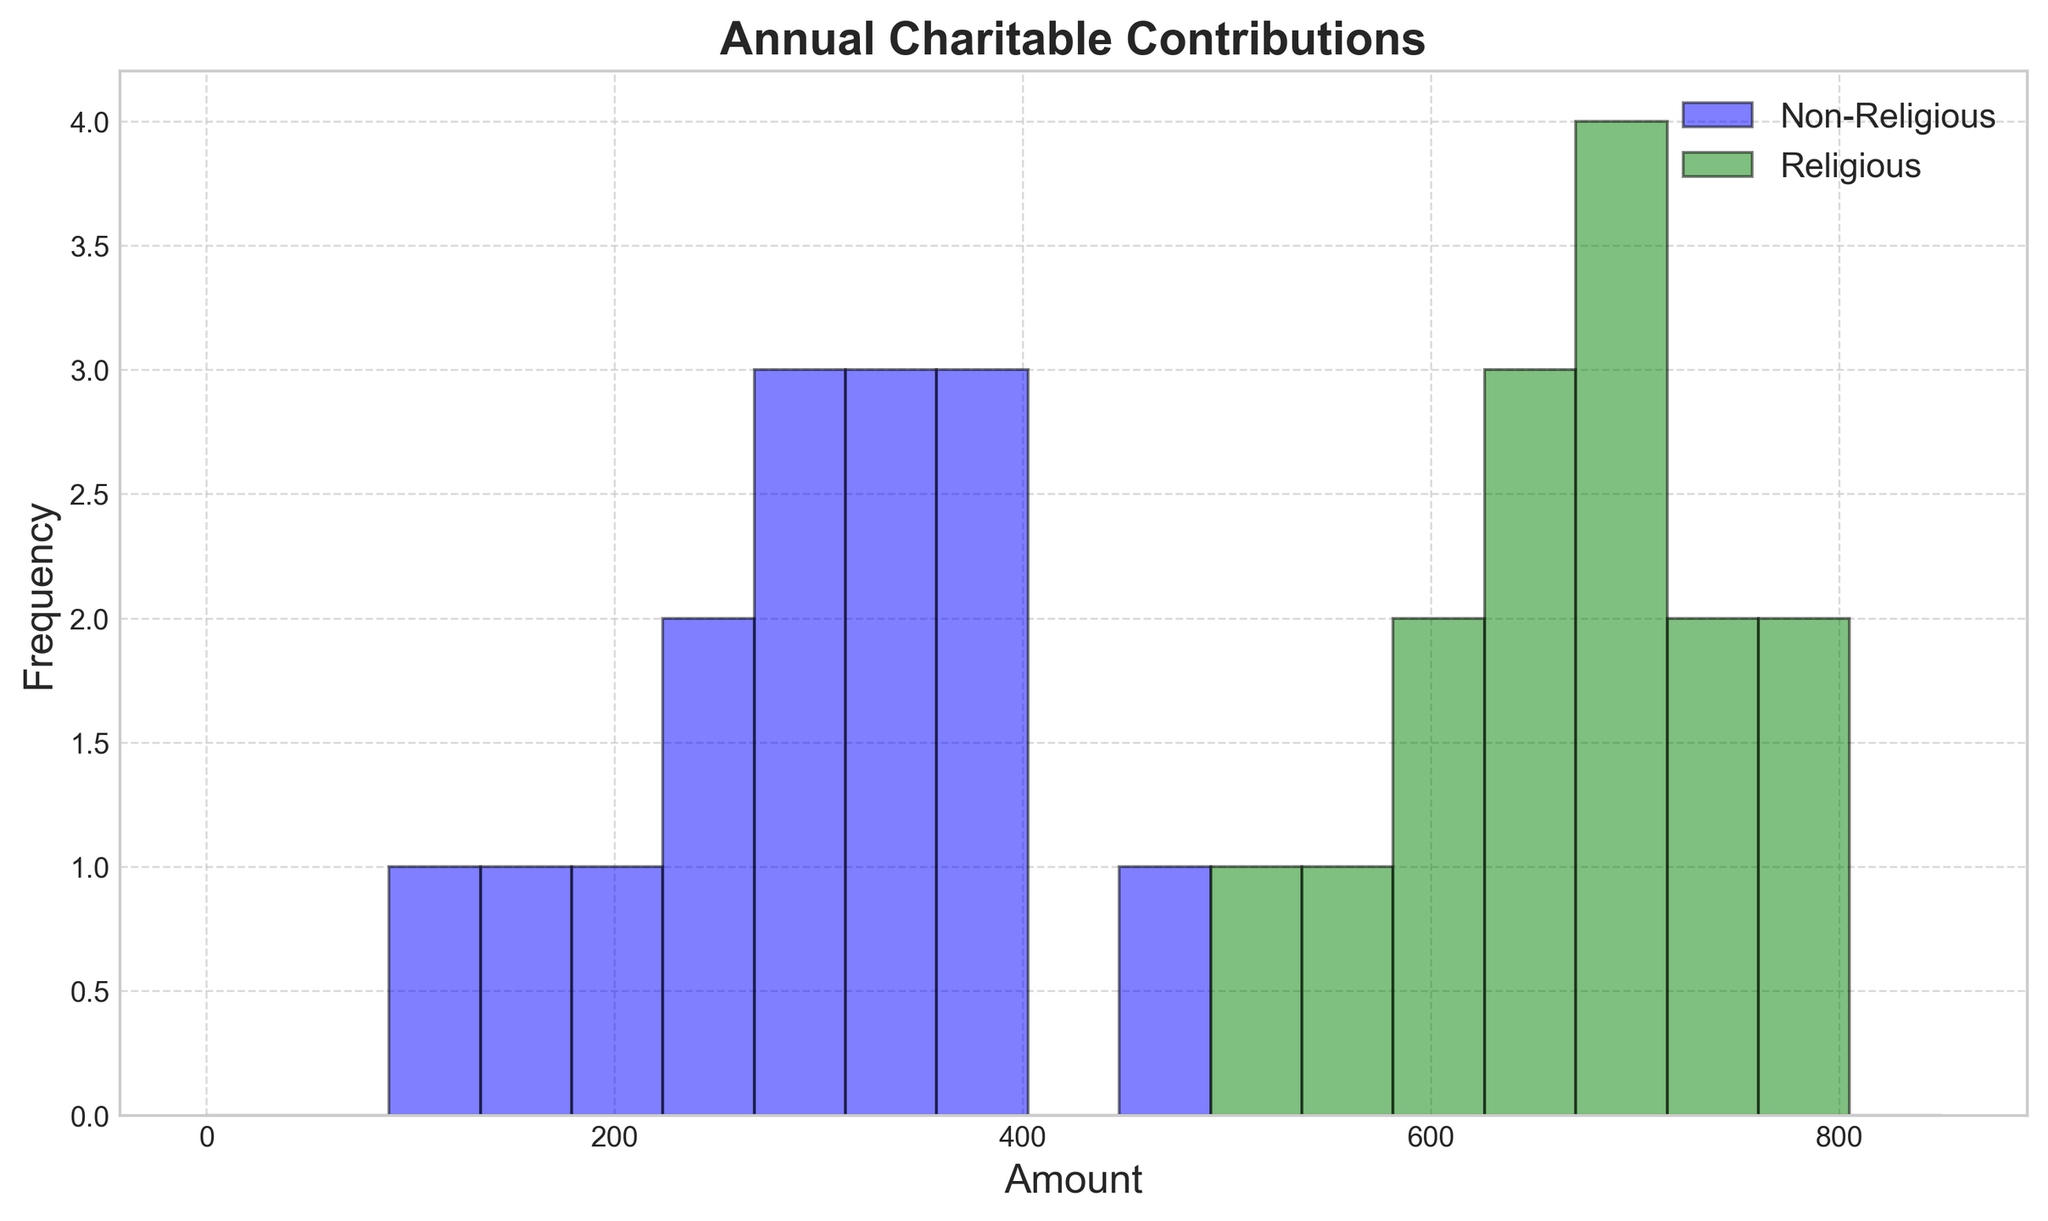What's the range of charitable contributions for non-religious individuals? The range indicates the difference between the maximum and minimum values. For non-religious individuals, the maximum contribution is 450, and the minimum is 100. Therefore, the range is 450 - 100 = 350.
Answer: 350 Which group has higher charitable contributions on average? To find the average, sum all the contributions for each group and divide by the number of contributions. The sum for non-religious is 4910 and for religious is 10260. There are 15 individuals in each group. Hence, the average for non-religious is 4910 / 15 ≈ 327.33 and for religious it is 10260 / 15 = 684. The religious group has higher average contributions.
Answer: Religious How do the modes of charitable contributions compare between the two groups? The mode is the value that appears most frequently. For non-religious, most values are unique, with no clear mode. For religious individuals, 800 appears twice, which is the highest frequency. Hence, the mode for religious individuals is 800, while non-religious has no mode.
Answer: Religious: 800, Non-Religious: None What is the frequency of the highest contribution range (750-800) for religious individuals compared to non-religious? By observing the histogram, count the frequency of contributions between 750-800. For religious individuals, this range appears 4 times. Non-religious contributions do not fall in this range.
Answer: 4 vs. 0 Which group shows a more even distribution of charitable contributions? A more even distribution indicates less variability. Observing the histograms, the non-religious group has contributions spread more evenly across the range, while the religious group has clusters around higher values (600-800).
Answer: Non-Religious Within which range do most of the non-religious individuals' contributions fall? By observing the peaks of the histogram for non-religious individuals, most contributions fall within the 200-400 range.
Answer: 200-400 What is the median contribution of religious individuals? To find the median, sort the contributions and find the middle value. Sorting the religious contributions (500, 550, 600, 620, 640, 650, 670, 680, 690, 700, 710, 720, 750, 800, 800), the median is the 8th value, which is 670.
Answer: 670 What is the overall distribution trend of contributions for both groups? The non-religious group shows lower end contributions, peaking around mid-ranges, whereas the religious group peaks at higher ranges (600-800), indicating more significant contributions.
Answer: Non-Religious: Lower and mid-range; Religious: Higher range How many bins in the histogram contain contributions exclusively from one group? Observing the histogram, certain bins only have contributions from one group. Contributions in 0-100 and 700-800 are exclusively from religious individuals, while 200-300 contributions are from non-religious individuals.
Answer: 3 bins Are there any overlaps in the contribution ranges between the two groups? By examining the two histograms, there are overlaps in contribution ranges from roughly 250 to 700. Both groups contribute within this range.
Answer: Yes 